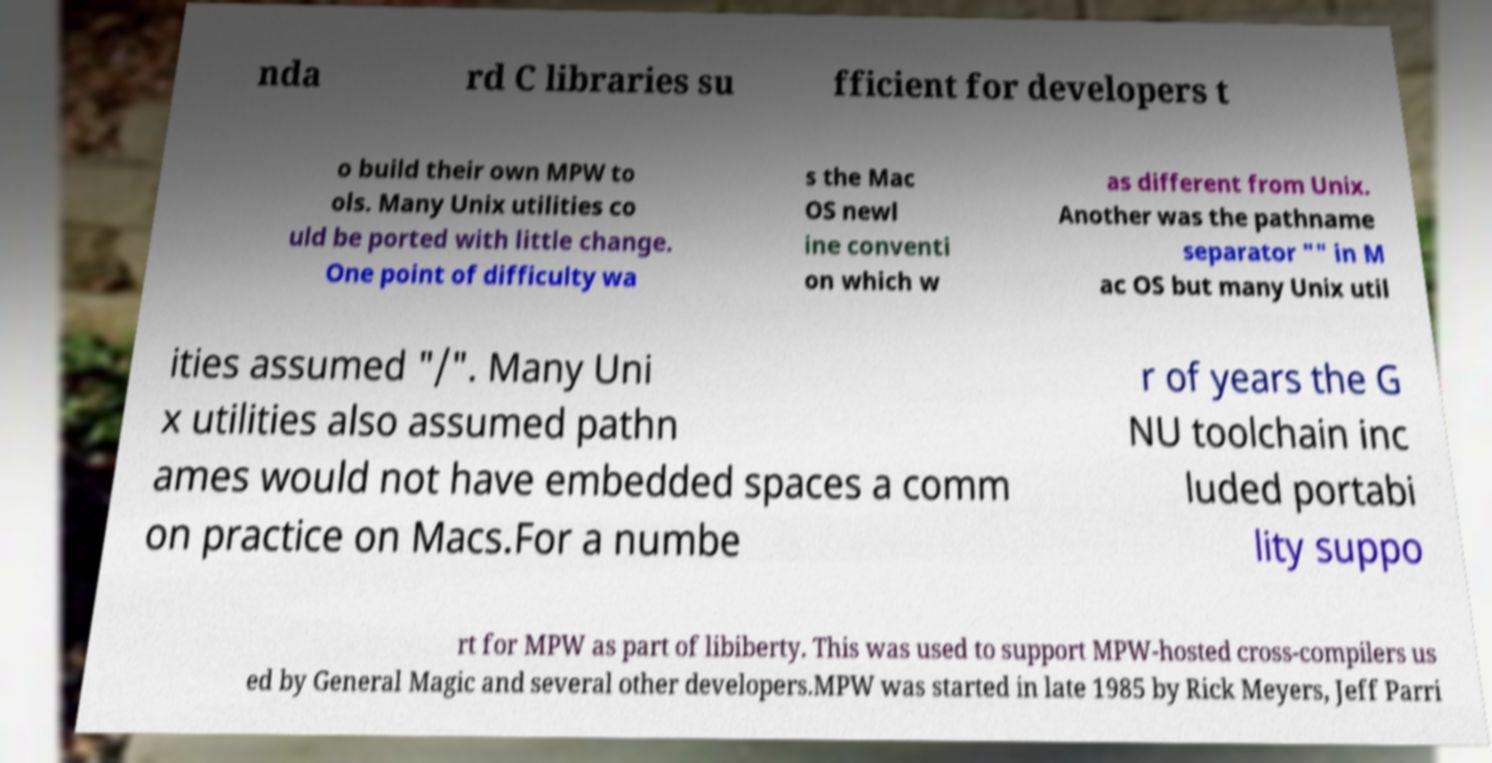Please identify and transcribe the text found in this image. nda rd C libraries su fficient for developers t o build their own MPW to ols. Many Unix utilities co uld be ported with little change. One point of difficulty wa s the Mac OS newl ine conventi on which w as different from Unix. Another was the pathname separator "" in M ac OS but many Unix util ities assumed "/". Many Uni x utilities also assumed pathn ames would not have embedded spaces a comm on practice on Macs.For a numbe r of years the G NU toolchain inc luded portabi lity suppo rt for MPW as part of libiberty. This was used to support MPW-hosted cross-compilers us ed by General Magic and several other developers.MPW was started in late 1985 by Rick Meyers, Jeff Parri 